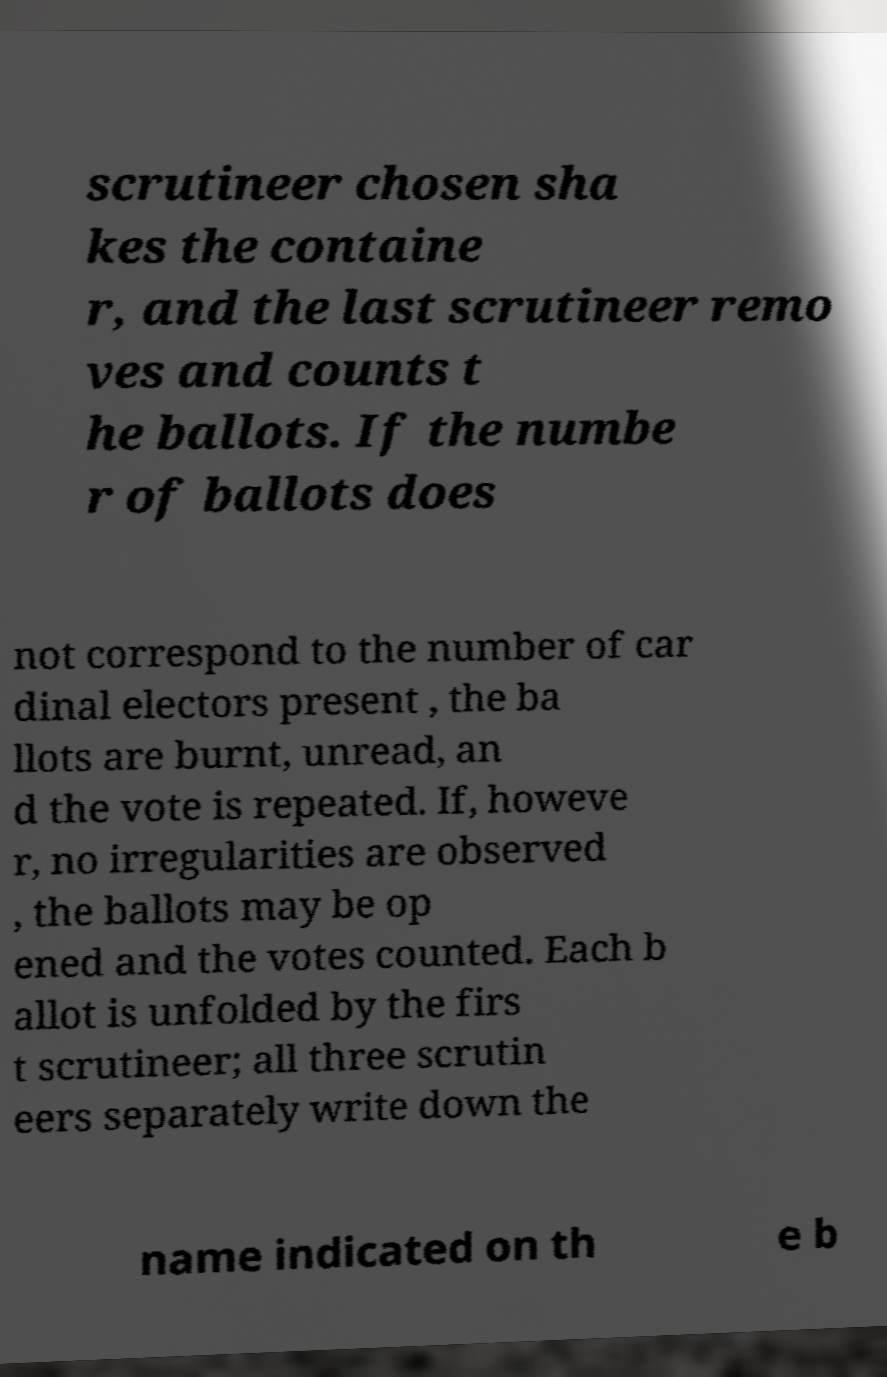I need the written content from this picture converted into text. Can you do that? scrutineer chosen sha kes the containe r, and the last scrutineer remo ves and counts t he ballots. If the numbe r of ballots does not correspond to the number of car dinal electors present , the ba llots are burnt, unread, an d the vote is repeated. If, howeve r, no irregularities are observed , the ballots may be op ened and the votes counted. Each b allot is unfolded by the firs t scrutineer; all three scrutin eers separately write down the name indicated on th e b 